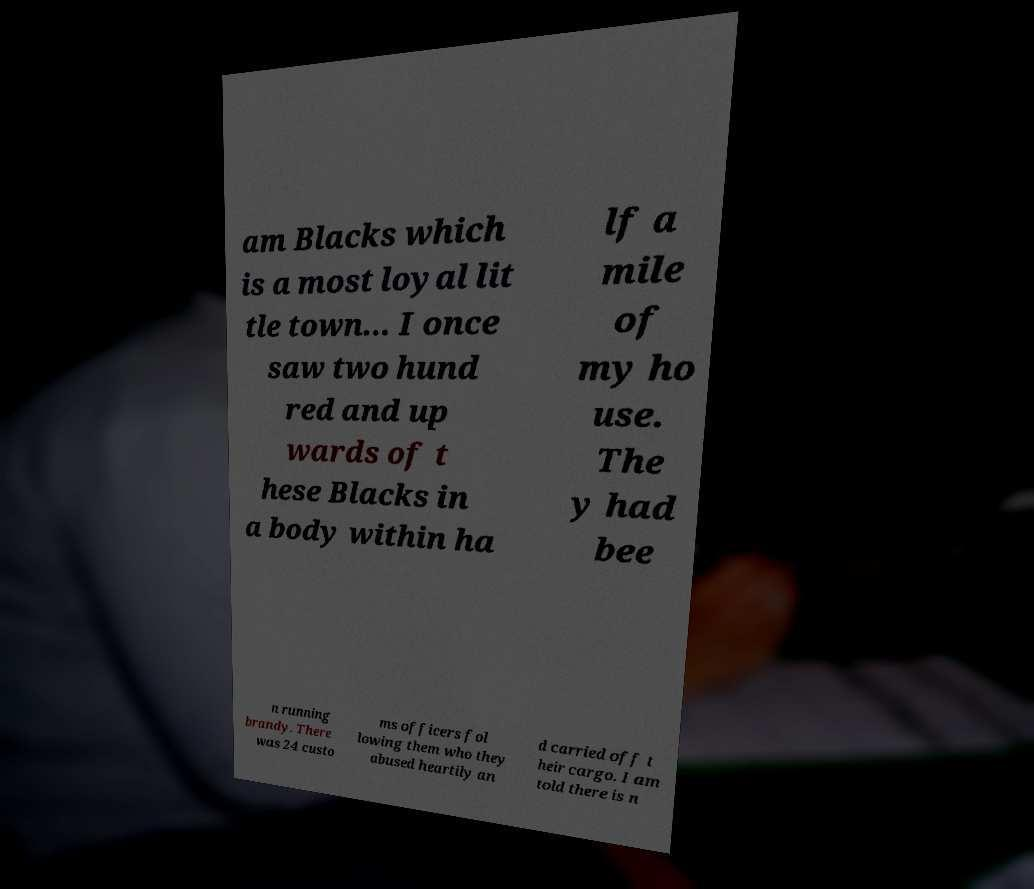What messages or text are displayed in this image? I need them in a readable, typed format. am Blacks which is a most loyal lit tle town... I once saw two hund red and up wards of t hese Blacks in a body within ha lf a mile of my ho use. The y had bee n running brandy. There was 24 custo ms officers fol lowing them who they abused heartily an d carried off t heir cargo. I am told there is n 